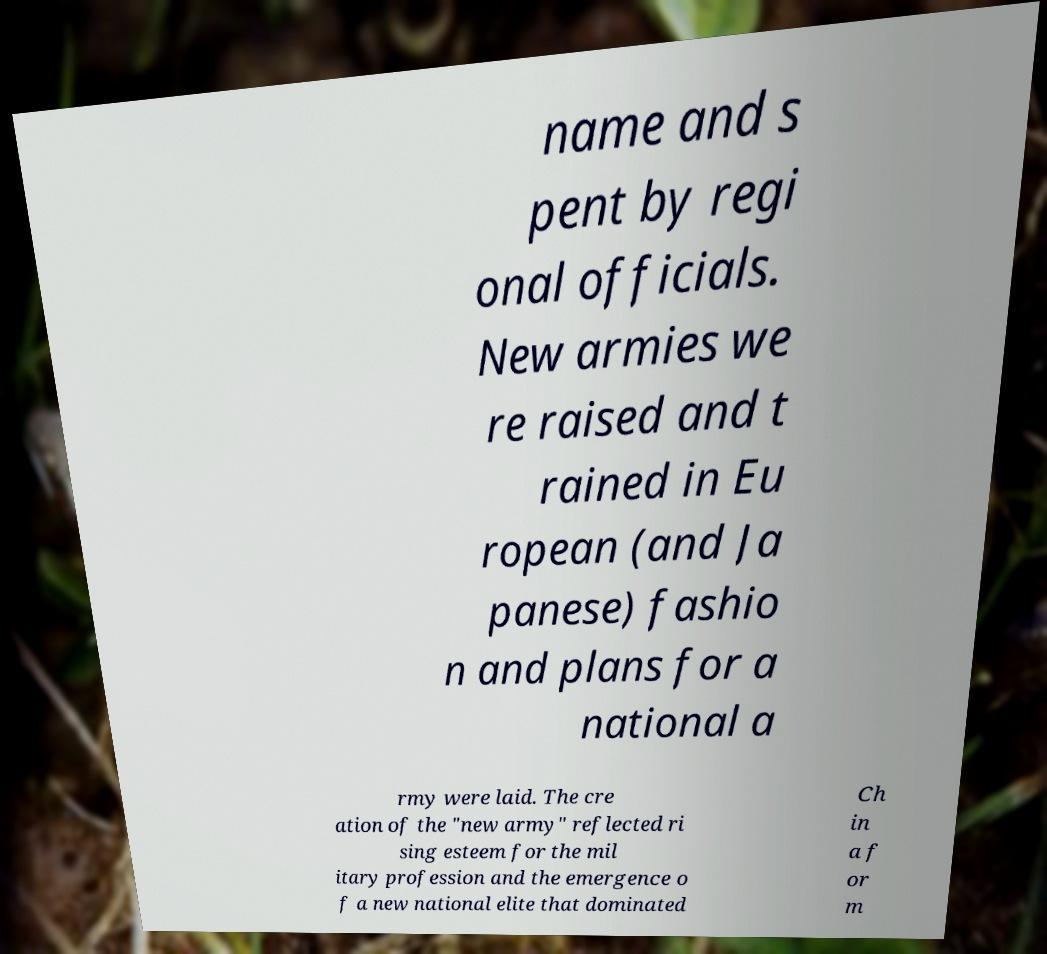Can you accurately transcribe the text from the provided image for me? name and s pent by regi onal officials. New armies we re raised and t rained in Eu ropean (and Ja panese) fashio n and plans for a national a rmy were laid. The cre ation of the "new army" reflected ri sing esteem for the mil itary profession and the emergence o f a new national elite that dominated Ch in a f or m 